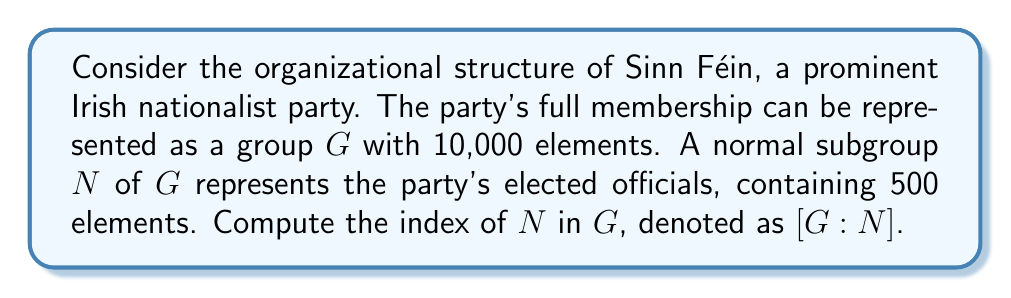Give your solution to this math problem. To solve this problem, we need to understand the concept of index in group theory and how it applies to the given political party structure.

1. The index of a subgroup H in a group G, denoted [G:H], is defined as the number of distinct left (or right) cosets of H in G.

2. For finite groups, the index is equal to the ratio of the order of G to the order of H:

   $$ [G:H] = \frac{|G|}{|H|} $$

   where |G| represents the order (number of elements) of group G, and |H| represents the order of subgroup H.

3. In this case, we have:
   - G: the full membership of Sinn Féin (10,000 elements)
   - N: the normal subgroup of elected officials (500 elements)

4. Applying the formula:

   $$ [G:N] = \frac{|G|}{|N|} = \frac{10,000}{500} $$

5. Simplifying the fraction:

   $$ [G:N] = \frac{10,000}{500} = 20 $$

This result indicates that there are 20 distinct cosets of N in G, which can be interpreted as 20 different categories or levels of party membership beyond the elected officials.
Answer: $[G:N] = 20$ 